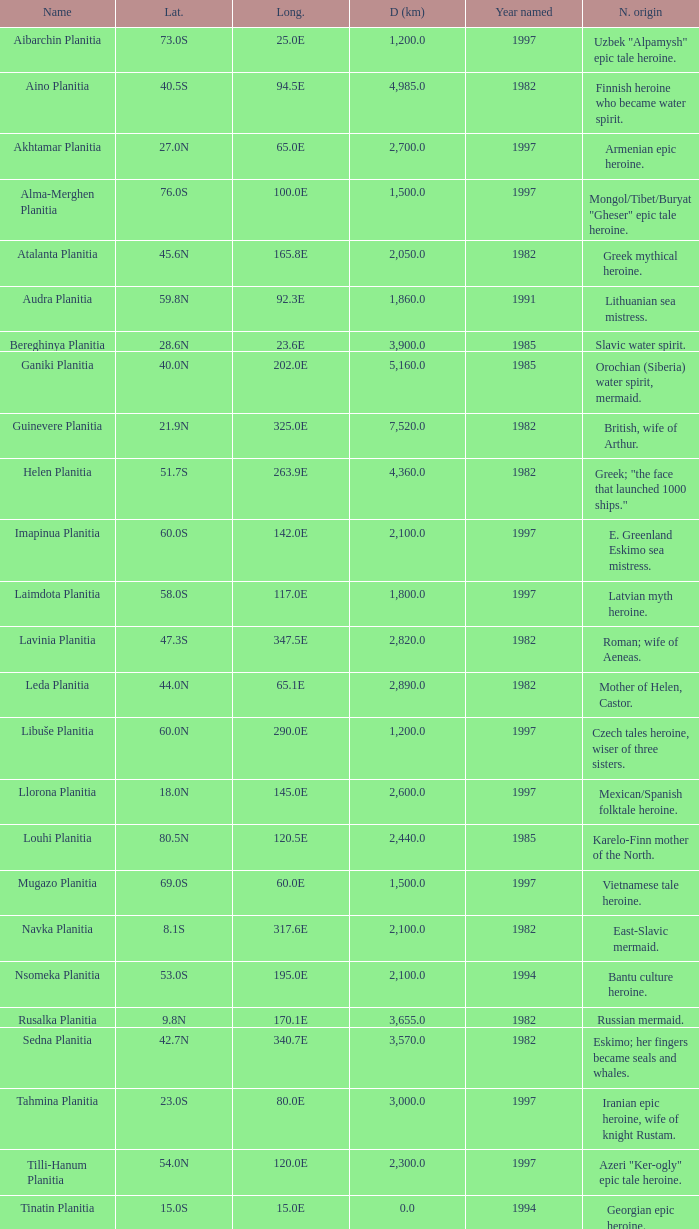What is the diameter (km) of the feature of latitude 23.0s 3000.0. 